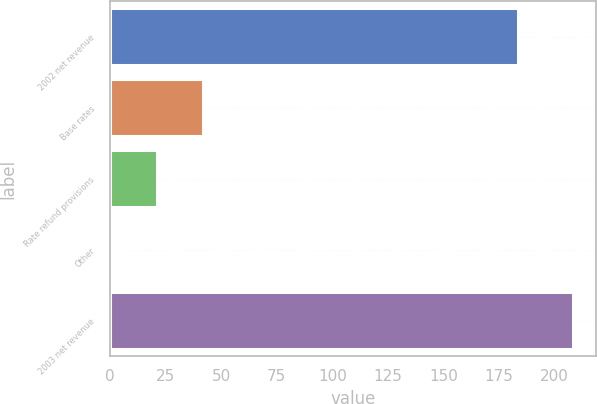<chart> <loc_0><loc_0><loc_500><loc_500><bar_chart><fcel>2002 net revenue<fcel>Base rates<fcel>Rate refund provisions<fcel>Other<fcel>2003 net revenue<nl><fcel>183.7<fcel>41.98<fcel>21.19<fcel>0.4<fcel>208.3<nl></chart> 